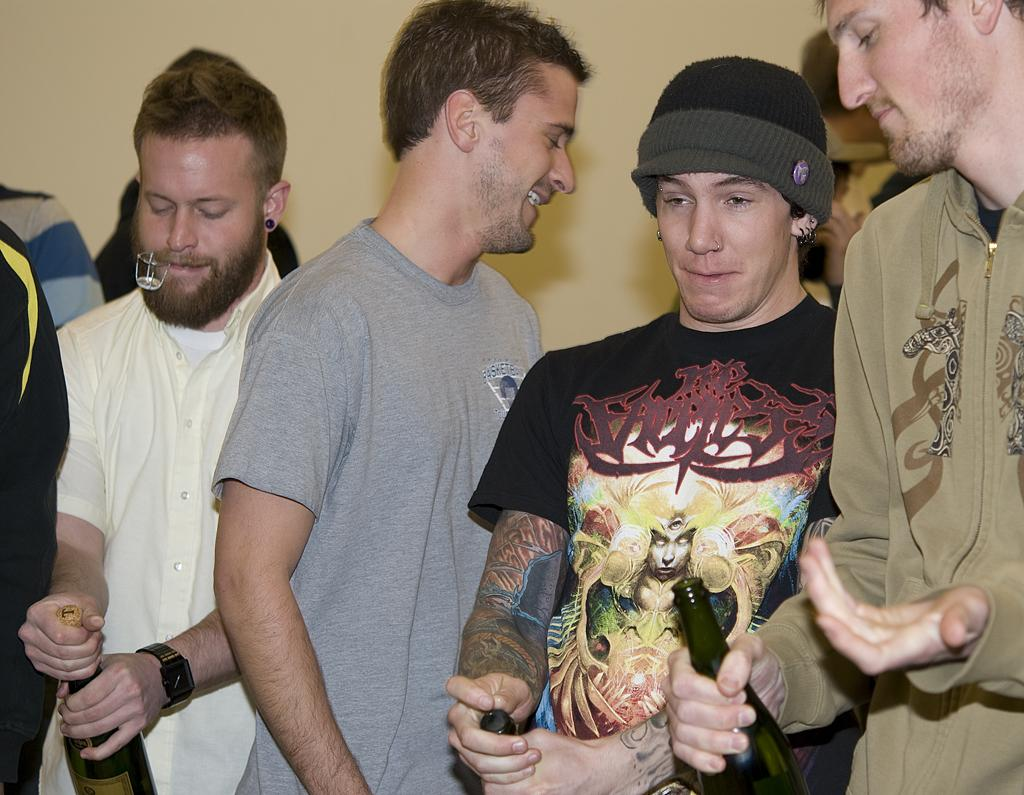Who is on the right side of the image? There is a man standing on the right side of the image. What is the man holding? The man is holding a wine bottle. Can you describe the person beside the man on the right side? The person is wearing a black color t-shirt and a cap. How many men are on the left side of the image? There are two men on the left side of the image. What type of bead is used to stop the car in the image? There is no car or brake present in the image, so it is not possible to determine what type of bead might be used. 